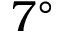Convert formula to latex. <formula><loc_0><loc_0><loc_500><loc_500>7 ^ { \circ }</formula> 